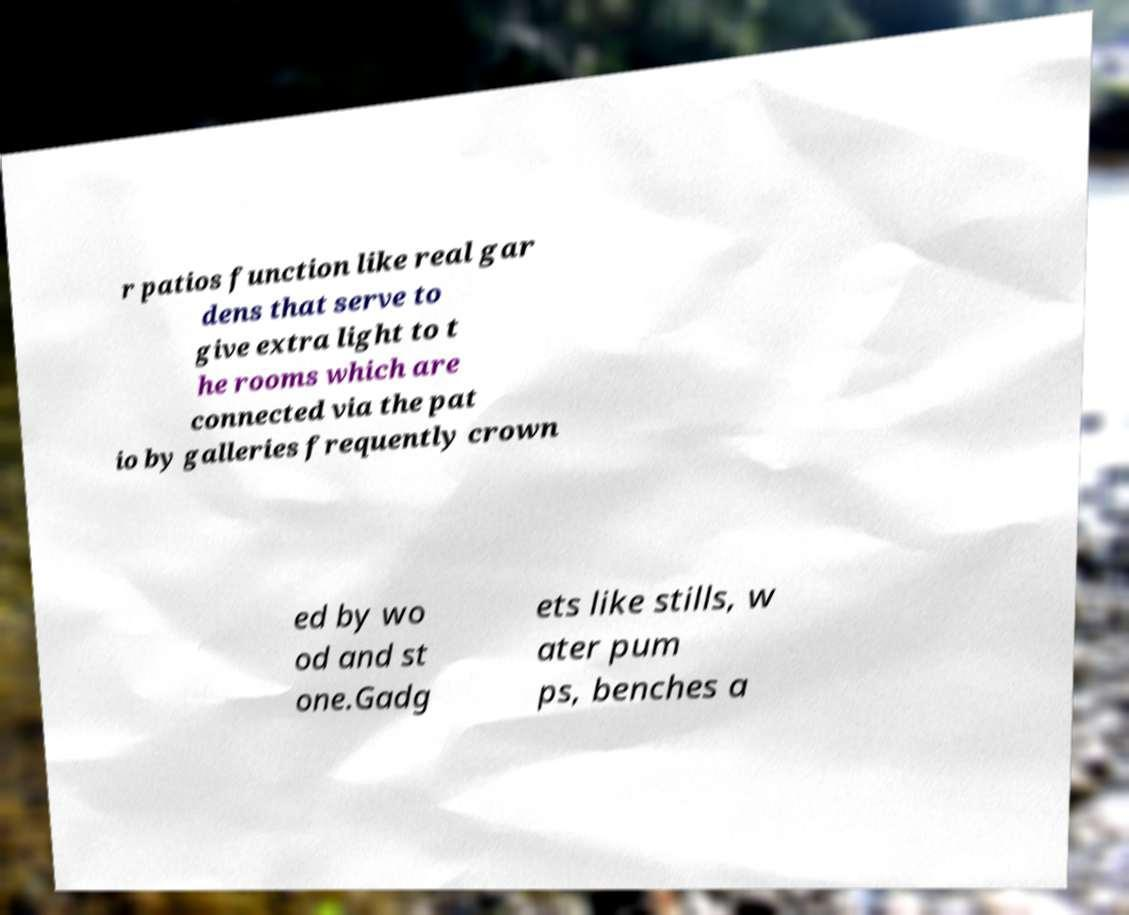What messages or text are displayed in this image? I need them in a readable, typed format. r patios function like real gar dens that serve to give extra light to t he rooms which are connected via the pat io by galleries frequently crown ed by wo od and st one.Gadg ets like stills, w ater pum ps, benches a 